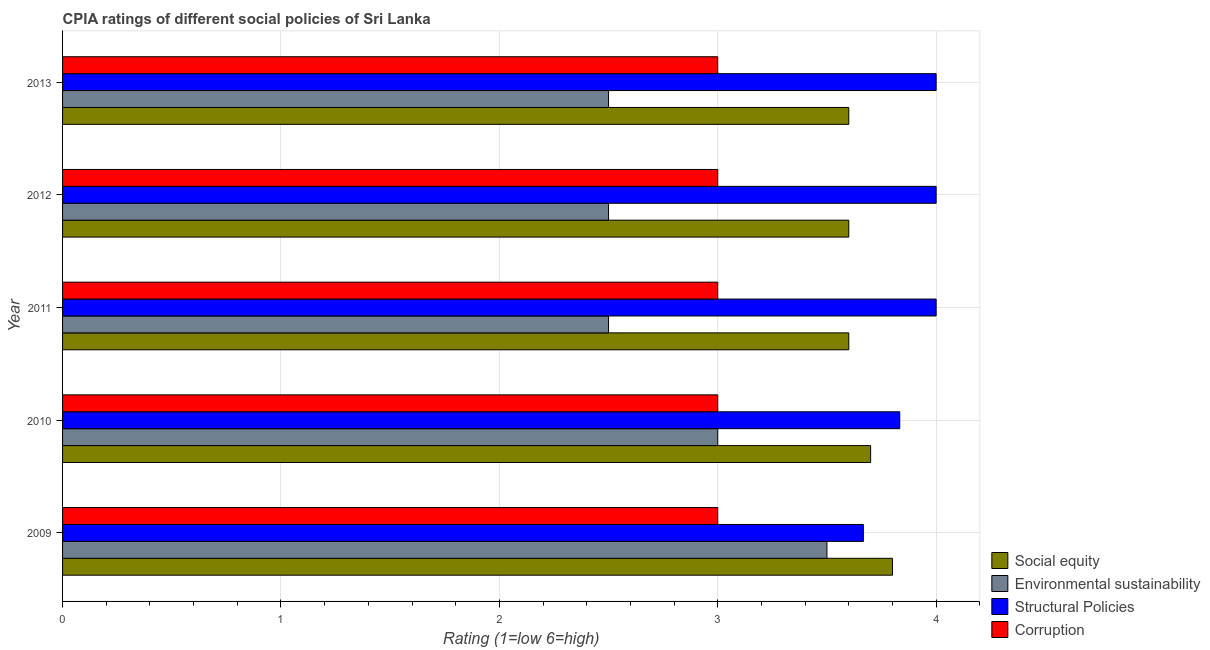How many groups of bars are there?
Provide a succinct answer. 5. Are the number of bars per tick equal to the number of legend labels?
Provide a short and direct response. Yes. How many bars are there on the 4th tick from the bottom?
Offer a terse response. 4. What is the label of the 1st group of bars from the top?
Make the answer very short. 2013. In how many cases, is the number of bars for a given year not equal to the number of legend labels?
Give a very brief answer. 0. What is the cpia rating of structural policies in 2009?
Provide a succinct answer. 3.67. In which year was the cpia rating of structural policies maximum?
Give a very brief answer. 2011. What is the total cpia rating of corruption in the graph?
Offer a very short reply. 15. What is the difference between the cpia rating of environmental sustainability in 2009 and that in 2010?
Make the answer very short. 0.5. What is the difference between the cpia rating of corruption in 2010 and the cpia rating of environmental sustainability in 2012?
Your response must be concise. 0.5. What is the ratio of the cpia rating of environmental sustainability in 2009 to that in 2011?
Offer a very short reply. 1.4. Is the cpia rating of corruption in 2011 less than that in 2012?
Ensure brevity in your answer.  No. Is the difference between the cpia rating of corruption in 2010 and 2011 greater than the difference between the cpia rating of environmental sustainability in 2010 and 2011?
Your response must be concise. No. What is the difference between the highest and the lowest cpia rating of corruption?
Your answer should be compact. 0. In how many years, is the cpia rating of structural policies greater than the average cpia rating of structural policies taken over all years?
Provide a succinct answer. 3. Is the sum of the cpia rating of structural policies in 2009 and 2012 greater than the maximum cpia rating of social equity across all years?
Your answer should be compact. Yes. Is it the case that in every year, the sum of the cpia rating of social equity and cpia rating of structural policies is greater than the sum of cpia rating of corruption and cpia rating of environmental sustainability?
Your answer should be compact. Yes. What does the 1st bar from the top in 2010 represents?
Ensure brevity in your answer.  Corruption. What does the 3rd bar from the bottom in 2011 represents?
Offer a very short reply. Structural Policies. Is it the case that in every year, the sum of the cpia rating of social equity and cpia rating of environmental sustainability is greater than the cpia rating of structural policies?
Give a very brief answer. Yes. Are all the bars in the graph horizontal?
Your answer should be very brief. Yes. How many years are there in the graph?
Make the answer very short. 5. What is the difference between two consecutive major ticks on the X-axis?
Offer a terse response. 1. Does the graph contain any zero values?
Your answer should be compact. No. Where does the legend appear in the graph?
Provide a short and direct response. Bottom right. How many legend labels are there?
Your answer should be compact. 4. What is the title of the graph?
Provide a succinct answer. CPIA ratings of different social policies of Sri Lanka. Does "Salary of employees" appear as one of the legend labels in the graph?
Offer a very short reply. No. What is the label or title of the X-axis?
Provide a succinct answer. Rating (1=low 6=high). What is the label or title of the Y-axis?
Your response must be concise. Year. What is the Rating (1=low 6=high) of Social equity in 2009?
Provide a succinct answer. 3.8. What is the Rating (1=low 6=high) in Environmental sustainability in 2009?
Your answer should be compact. 3.5. What is the Rating (1=low 6=high) of Structural Policies in 2009?
Ensure brevity in your answer.  3.67. What is the Rating (1=low 6=high) in Corruption in 2009?
Provide a succinct answer. 3. What is the Rating (1=low 6=high) of Structural Policies in 2010?
Your answer should be very brief. 3.83. What is the Rating (1=low 6=high) in Social equity in 2011?
Keep it short and to the point. 3.6. What is the Rating (1=low 6=high) of Environmental sustainability in 2011?
Ensure brevity in your answer.  2.5. What is the Rating (1=low 6=high) of Corruption in 2011?
Give a very brief answer. 3. What is the Rating (1=low 6=high) of Social equity in 2012?
Provide a short and direct response. 3.6. What is the Rating (1=low 6=high) of Environmental sustainability in 2012?
Your answer should be very brief. 2.5. What is the Rating (1=low 6=high) of Structural Policies in 2012?
Your answer should be compact. 4. What is the Rating (1=low 6=high) in Corruption in 2012?
Offer a very short reply. 3. What is the Rating (1=low 6=high) in Environmental sustainability in 2013?
Make the answer very short. 2.5. What is the Rating (1=low 6=high) in Corruption in 2013?
Give a very brief answer. 3. Across all years, what is the maximum Rating (1=low 6=high) in Structural Policies?
Give a very brief answer. 4. Across all years, what is the maximum Rating (1=low 6=high) of Corruption?
Ensure brevity in your answer.  3. Across all years, what is the minimum Rating (1=low 6=high) of Environmental sustainability?
Keep it short and to the point. 2.5. Across all years, what is the minimum Rating (1=low 6=high) of Structural Policies?
Your answer should be compact. 3.67. Across all years, what is the minimum Rating (1=low 6=high) in Corruption?
Give a very brief answer. 3. What is the total Rating (1=low 6=high) in Environmental sustainability in the graph?
Offer a very short reply. 14. What is the total Rating (1=low 6=high) of Structural Policies in the graph?
Give a very brief answer. 19.5. What is the difference between the Rating (1=low 6=high) of Social equity in 2009 and that in 2010?
Keep it short and to the point. 0.1. What is the difference between the Rating (1=low 6=high) in Structural Policies in 2009 and that in 2010?
Provide a short and direct response. -0.17. What is the difference between the Rating (1=low 6=high) of Corruption in 2009 and that in 2010?
Provide a short and direct response. 0. What is the difference between the Rating (1=low 6=high) in Social equity in 2009 and that in 2011?
Offer a very short reply. 0.2. What is the difference between the Rating (1=low 6=high) in Corruption in 2009 and that in 2011?
Your response must be concise. 0. What is the difference between the Rating (1=low 6=high) of Social equity in 2009 and that in 2012?
Your response must be concise. 0.2. What is the difference between the Rating (1=low 6=high) of Environmental sustainability in 2009 and that in 2012?
Offer a very short reply. 1. What is the difference between the Rating (1=low 6=high) in Structural Policies in 2009 and that in 2012?
Your answer should be compact. -0.33. What is the difference between the Rating (1=low 6=high) of Corruption in 2009 and that in 2012?
Make the answer very short. 0. What is the difference between the Rating (1=low 6=high) in Social equity in 2009 and that in 2013?
Your response must be concise. 0.2. What is the difference between the Rating (1=low 6=high) in Environmental sustainability in 2010 and that in 2011?
Your answer should be compact. 0.5. What is the difference between the Rating (1=low 6=high) of Structural Policies in 2010 and that in 2011?
Offer a terse response. -0.17. What is the difference between the Rating (1=low 6=high) of Corruption in 2010 and that in 2011?
Keep it short and to the point. 0. What is the difference between the Rating (1=low 6=high) in Social equity in 2010 and that in 2012?
Keep it short and to the point. 0.1. What is the difference between the Rating (1=low 6=high) of Environmental sustainability in 2010 and that in 2012?
Provide a short and direct response. 0.5. What is the difference between the Rating (1=low 6=high) of Social equity in 2010 and that in 2013?
Your answer should be very brief. 0.1. What is the difference between the Rating (1=low 6=high) in Environmental sustainability in 2010 and that in 2013?
Ensure brevity in your answer.  0.5. What is the difference between the Rating (1=low 6=high) of Corruption in 2010 and that in 2013?
Provide a short and direct response. 0. What is the difference between the Rating (1=low 6=high) of Social equity in 2011 and that in 2012?
Offer a very short reply. 0. What is the difference between the Rating (1=low 6=high) in Environmental sustainability in 2011 and that in 2012?
Keep it short and to the point. 0. What is the difference between the Rating (1=low 6=high) of Social equity in 2011 and that in 2013?
Provide a short and direct response. 0. What is the difference between the Rating (1=low 6=high) in Structural Policies in 2011 and that in 2013?
Offer a terse response. 0. What is the difference between the Rating (1=low 6=high) of Social equity in 2012 and that in 2013?
Give a very brief answer. 0. What is the difference between the Rating (1=low 6=high) in Environmental sustainability in 2012 and that in 2013?
Provide a short and direct response. 0. What is the difference between the Rating (1=low 6=high) of Corruption in 2012 and that in 2013?
Make the answer very short. 0. What is the difference between the Rating (1=low 6=high) in Social equity in 2009 and the Rating (1=low 6=high) in Environmental sustainability in 2010?
Provide a short and direct response. 0.8. What is the difference between the Rating (1=low 6=high) in Social equity in 2009 and the Rating (1=low 6=high) in Structural Policies in 2010?
Provide a short and direct response. -0.03. What is the difference between the Rating (1=low 6=high) in Environmental sustainability in 2009 and the Rating (1=low 6=high) in Structural Policies in 2010?
Your answer should be very brief. -0.33. What is the difference between the Rating (1=low 6=high) in Structural Policies in 2009 and the Rating (1=low 6=high) in Corruption in 2010?
Make the answer very short. 0.67. What is the difference between the Rating (1=low 6=high) in Social equity in 2009 and the Rating (1=low 6=high) in Structural Policies in 2011?
Ensure brevity in your answer.  -0.2. What is the difference between the Rating (1=low 6=high) in Social equity in 2009 and the Rating (1=low 6=high) in Corruption in 2011?
Your answer should be very brief. 0.8. What is the difference between the Rating (1=low 6=high) in Environmental sustainability in 2009 and the Rating (1=low 6=high) in Structural Policies in 2011?
Your answer should be compact. -0.5. What is the difference between the Rating (1=low 6=high) in Environmental sustainability in 2009 and the Rating (1=low 6=high) in Corruption in 2011?
Your response must be concise. 0.5. What is the difference between the Rating (1=low 6=high) of Structural Policies in 2009 and the Rating (1=low 6=high) of Corruption in 2012?
Your response must be concise. 0.67. What is the difference between the Rating (1=low 6=high) of Social equity in 2009 and the Rating (1=low 6=high) of Environmental sustainability in 2013?
Make the answer very short. 1.3. What is the difference between the Rating (1=low 6=high) in Social equity in 2009 and the Rating (1=low 6=high) in Corruption in 2013?
Provide a short and direct response. 0.8. What is the difference between the Rating (1=low 6=high) in Environmental sustainability in 2009 and the Rating (1=low 6=high) in Corruption in 2013?
Provide a succinct answer. 0.5. What is the difference between the Rating (1=low 6=high) of Structural Policies in 2009 and the Rating (1=low 6=high) of Corruption in 2013?
Provide a succinct answer. 0.67. What is the difference between the Rating (1=low 6=high) in Social equity in 2010 and the Rating (1=low 6=high) in Environmental sustainability in 2011?
Keep it short and to the point. 1.2. What is the difference between the Rating (1=low 6=high) of Social equity in 2010 and the Rating (1=low 6=high) of Structural Policies in 2011?
Provide a short and direct response. -0.3. What is the difference between the Rating (1=low 6=high) of Social equity in 2010 and the Rating (1=low 6=high) of Corruption in 2011?
Offer a very short reply. 0.7. What is the difference between the Rating (1=low 6=high) of Environmental sustainability in 2010 and the Rating (1=low 6=high) of Corruption in 2011?
Give a very brief answer. 0. What is the difference between the Rating (1=low 6=high) in Structural Policies in 2010 and the Rating (1=low 6=high) in Corruption in 2011?
Provide a short and direct response. 0.83. What is the difference between the Rating (1=low 6=high) in Social equity in 2010 and the Rating (1=low 6=high) in Environmental sustainability in 2012?
Ensure brevity in your answer.  1.2. What is the difference between the Rating (1=low 6=high) in Social equity in 2010 and the Rating (1=low 6=high) in Structural Policies in 2012?
Give a very brief answer. -0.3. What is the difference between the Rating (1=low 6=high) in Environmental sustainability in 2010 and the Rating (1=low 6=high) in Structural Policies in 2012?
Offer a very short reply. -1. What is the difference between the Rating (1=low 6=high) of Structural Policies in 2010 and the Rating (1=low 6=high) of Corruption in 2012?
Keep it short and to the point. 0.83. What is the difference between the Rating (1=low 6=high) in Social equity in 2010 and the Rating (1=low 6=high) in Environmental sustainability in 2013?
Your answer should be very brief. 1.2. What is the difference between the Rating (1=low 6=high) of Social equity in 2010 and the Rating (1=low 6=high) of Structural Policies in 2013?
Provide a short and direct response. -0.3. What is the difference between the Rating (1=low 6=high) of Social equity in 2010 and the Rating (1=low 6=high) of Corruption in 2013?
Keep it short and to the point. 0.7. What is the difference between the Rating (1=low 6=high) in Structural Policies in 2010 and the Rating (1=low 6=high) in Corruption in 2013?
Ensure brevity in your answer.  0.83. What is the difference between the Rating (1=low 6=high) in Social equity in 2011 and the Rating (1=low 6=high) in Environmental sustainability in 2012?
Make the answer very short. 1.1. What is the difference between the Rating (1=low 6=high) of Social equity in 2011 and the Rating (1=low 6=high) of Structural Policies in 2012?
Make the answer very short. -0.4. What is the difference between the Rating (1=low 6=high) in Social equity in 2011 and the Rating (1=low 6=high) in Corruption in 2012?
Make the answer very short. 0.6. What is the difference between the Rating (1=low 6=high) in Environmental sustainability in 2011 and the Rating (1=low 6=high) in Structural Policies in 2012?
Your answer should be compact. -1.5. What is the difference between the Rating (1=low 6=high) of Social equity in 2011 and the Rating (1=low 6=high) of Environmental sustainability in 2013?
Provide a short and direct response. 1.1. What is the difference between the Rating (1=low 6=high) in Environmental sustainability in 2011 and the Rating (1=low 6=high) in Structural Policies in 2013?
Your response must be concise. -1.5. What is the difference between the Rating (1=low 6=high) in Environmental sustainability in 2011 and the Rating (1=low 6=high) in Corruption in 2013?
Ensure brevity in your answer.  -0.5. What is the difference between the Rating (1=low 6=high) of Structural Policies in 2011 and the Rating (1=low 6=high) of Corruption in 2013?
Provide a succinct answer. 1. What is the difference between the Rating (1=low 6=high) of Social equity in 2012 and the Rating (1=low 6=high) of Corruption in 2013?
Give a very brief answer. 0.6. What is the average Rating (1=low 6=high) of Social equity per year?
Ensure brevity in your answer.  3.66. What is the average Rating (1=low 6=high) of Environmental sustainability per year?
Offer a terse response. 2.8. What is the average Rating (1=low 6=high) in Corruption per year?
Keep it short and to the point. 3. In the year 2009, what is the difference between the Rating (1=low 6=high) of Social equity and Rating (1=low 6=high) of Structural Policies?
Your answer should be compact. 0.13. In the year 2009, what is the difference between the Rating (1=low 6=high) in Environmental sustainability and Rating (1=low 6=high) in Structural Policies?
Provide a short and direct response. -0.17. In the year 2009, what is the difference between the Rating (1=low 6=high) of Environmental sustainability and Rating (1=low 6=high) of Corruption?
Ensure brevity in your answer.  0.5. In the year 2010, what is the difference between the Rating (1=low 6=high) in Social equity and Rating (1=low 6=high) in Environmental sustainability?
Ensure brevity in your answer.  0.7. In the year 2010, what is the difference between the Rating (1=low 6=high) in Social equity and Rating (1=low 6=high) in Structural Policies?
Give a very brief answer. -0.13. In the year 2010, what is the difference between the Rating (1=low 6=high) of Social equity and Rating (1=low 6=high) of Corruption?
Your response must be concise. 0.7. In the year 2010, what is the difference between the Rating (1=low 6=high) in Environmental sustainability and Rating (1=low 6=high) in Corruption?
Your answer should be very brief. 0. In the year 2011, what is the difference between the Rating (1=low 6=high) of Social equity and Rating (1=low 6=high) of Environmental sustainability?
Your answer should be very brief. 1.1. In the year 2011, what is the difference between the Rating (1=low 6=high) of Social equity and Rating (1=low 6=high) of Corruption?
Your answer should be compact. 0.6. In the year 2011, what is the difference between the Rating (1=low 6=high) of Environmental sustainability and Rating (1=low 6=high) of Structural Policies?
Offer a terse response. -1.5. In the year 2011, what is the difference between the Rating (1=low 6=high) of Structural Policies and Rating (1=low 6=high) of Corruption?
Give a very brief answer. 1. In the year 2012, what is the difference between the Rating (1=low 6=high) of Environmental sustainability and Rating (1=low 6=high) of Structural Policies?
Give a very brief answer. -1.5. In the year 2012, what is the difference between the Rating (1=low 6=high) in Environmental sustainability and Rating (1=low 6=high) in Corruption?
Give a very brief answer. -0.5. In the year 2012, what is the difference between the Rating (1=low 6=high) of Structural Policies and Rating (1=low 6=high) of Corruption?
Ensure brevity in your answer.  1. In the year 2013, what is the difference between the Rating (1=low 6=high) in Social equity and Rating (1=low 6=high) in Corruption?
Make the answer very short. 0.6. In the year 2013, what is the difference between the Rating (1=low 6=high) of Environmental sustainability and Rating (1=low 6=high) of Structural Policies?
Your answer should be compact. -1.5. In the year 2013, what is the difference between the Rating (1=low 6=high) of Environmental sustainability and Rating (1=low 6=high) of Corruption?
Give a very brief answer. -0.5. In the year 2013, what is the difference between the Rating (1=low 6=high) in Structural Policies and Rating (1=low 6=high) in Corruption?
Offer a very short reply. 1. What is the ratio of the Rating (1=low 6=high) of Social equity in 2009 to that in 2010?
Your answer should be very brief. 1.03. What is the ratio of the Rating (1=low 6=high) in Structural Policies in 2009 to that in 2010?
Your answer should be very brief. 0.96. What is the ratio of the Rating (1=low 6=high) of Corruption in 2009 to that in 2010?
Give a very brief answer. 1. What is the ratio of the Rating (1=low 6=high) in Social equity in 2009 to that in 2011?
Your response must be concise. 1.06. What is the ratio of the Rating (1=low 6=high) in Environmental sustainability in 2009 to that in 2011?
Give a very brief answer. 1.4. What is the ratio of the Rating (1=low 6=high) of Structural Policies in 2009 to that in 2011?
Your answer should be very brief. 0.92. What is the ratio of the Rating (1=low 6=high) of Social equity in 2009 to that in 2012?
Keep it short and to the point. 1.06. What is the ratio of the Rating (1=low 6=high) in Environmental sustainability in 2009 to that in 2012?
Offer a terse response. 1.4. What is the ratio of the Rating (1=low 6=high) in Social equity in 2009 to that in 2013?
Your answer should be compact. 1.06. What is the ratio of the Rating (1=low 6=high) in Environmental sustainability in 2009 to that in 2013?
Make the answer very short. 1.4. What is the ratio of the Rating (1=low 6=high) of Structural Policies in 2009 to that in 2013?
Your answer should be very brief. 0.92. What is the ratio of the Rating (1=low 6=high) of Social equity in 2010 to that in 2011?
Give a very brief answer. 1.03. What is the ratio of the Rating (1=low 6=high) in Environmental sustainability in 2010 to that in 2011?
Keep it short and to the point. 1.2. What is the ratio of the Rating (1=low 6=high) of Social equity in 2010 to that in 2012?
Your answer should be very brief. 1.03. What is the ratio of the Rating (1=low 6=high) of Corruption in 2010 to that in 2012?
Your answer should be very brief. 1. What is the ratio of the Rating (1=low 6=high) of Social equity in 2010 to that in 2013?
Make the answer very short. 1.03. What is the ratio of the Rating (1=low 6=high) of Environmental sustainability in 2010 to that in 2013?
Your answer should be very brief. 1.2. What is the ratio of the Rating (1=low 6=high) in Environmental sustainability in 2011 to that in 2012?
Your answer should be very brief. 1. What is the ratio of the Rating (1=low 6=high) in Structural Policies in 2011 to that in 2012?
Give a very brief answer. 1. What is the ratio of the Rating (1=low 6=high) in Corruption in 2011 to that in 2012?
Provide a short and direct response. 1. What is the ratio of the Rating (1=low 6=high) of Environmental sustainability in 2011 to that in 2013?
Make the answer very short. 1. What is the ratio of the Rating (1=low 6=high) in Structural Policies in 2011 to that in 2013?
Keep it short and to the point. 1. What is the ratio of the Rating (1=low 6=high) of Corruption in 2011 to that in 2013?
Keep it short and to the point. 1. What is the ratio of the Rating (1=low 6=high) of Social equity in 2012 to that in 2013?
Offer a terse response. 1. What is the difference between the highest and the second highest Rating (1=low 6=high) in Social equity?
Your answer should be very brief. 0.1. What is the difference between the highest and the second highest Rating (1=low 6=high) in Environmental sustainability?
Offer a terse response. 0.5. What is the difference between the highest and the second highest Rating (1=low 6=high) in Structural Policies?
Your response must be concise. 0. What is the difference between the highest and the second highest Rating (1=low 6=high) of Corruption?
Your answer should be compact. 0. What is the difference between the highest and the lowest Rating (1=low 6=high) in Environmental sustainability?
Provide a succinct answer. 1. What is the difference between the highest and the lowest Rating (1=low 6=high) in Structural Policies?
Make the answer very short. 0.33. What is the difference between the highest and the lowest Rating (1=low 6=high) of Corruption?
Offer a terse response. 0. 